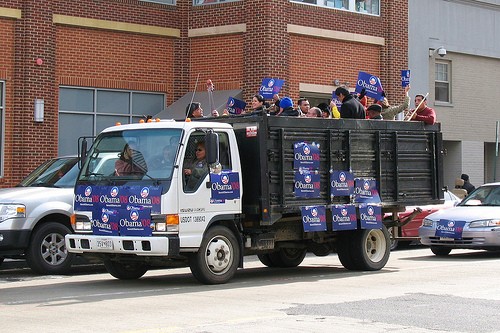What event does this scene likely depict? This scene likely depicts a political rally or campaign event in support of Barack Obama, as evidenced by the numerous Obama '08 signs on the truck and the people holding signs. 